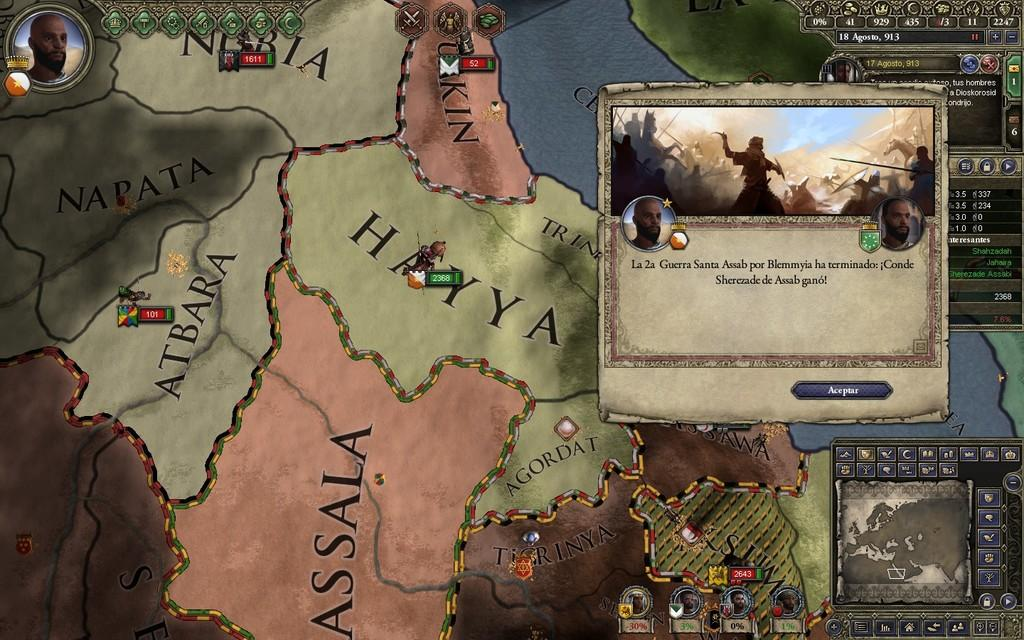What type of image is being depicted in the picture? The image is a map. Are there any additional elements on the map besides the geographical features? Yes, there are other pictures on the map. What type of kitten can be seen playing with a twig on the map? There is no kitten or twig present on the map; it is a geographical representation with other pictures. How does the hair on the map affect the accuracy of the geographical features? There is no hair present on the map; it is a geographical representation with other pictures. 